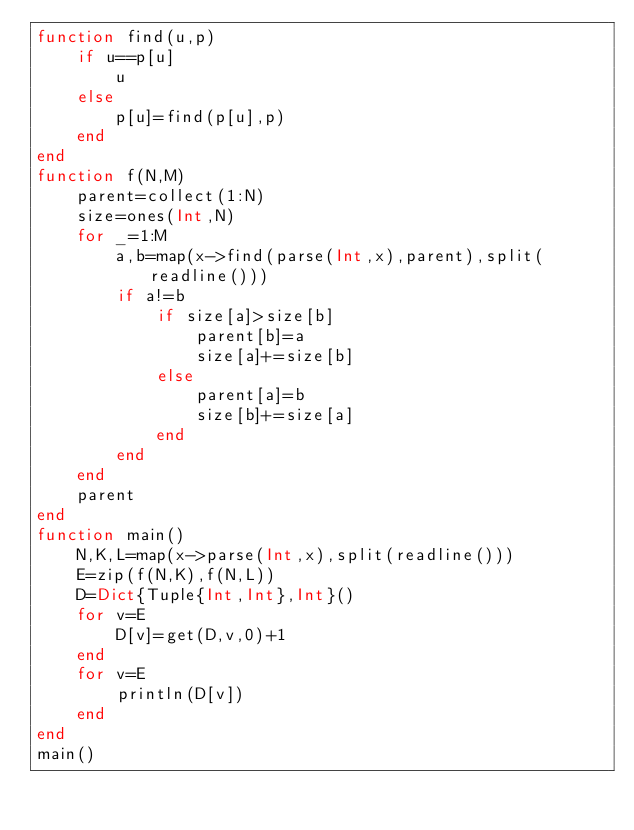Convert code to text. <code><loc_0><loc_0><loc_500><loc_500><_Julia_>function find(u,p)
	if u==p[u]
		u
	else
		p[u]=find(p[u],p)
	end
end
function f(N,M)
	parent=collect(1:N)
	size=ones(Int,N)
	for _=1:M
		a,b=map(x->find(parse(Int,x),parent),split(readline()))
		if a!=b
			if size[a]>size[b]
				parent[b]=a
				size[a]+=size[b]
			else
				parent[a]=b
				size[b]+=size[a]
			end
		end
	end
	parent
end
function main()
	N,K,L=map(x->parse(Int,x),split(readline()))
	E=zip(f(N,K),f(N,L))
	D=Dict{Tuple{Int,Int},Int}()
	for v=E
		D[v]=get(D,v,0)+1
	end
	for v=E
		println(D[v])
	end
end
main()</code> 